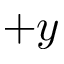<formula> <loc_0><loc_0><loc_500><loc_500>+ y</formula> 